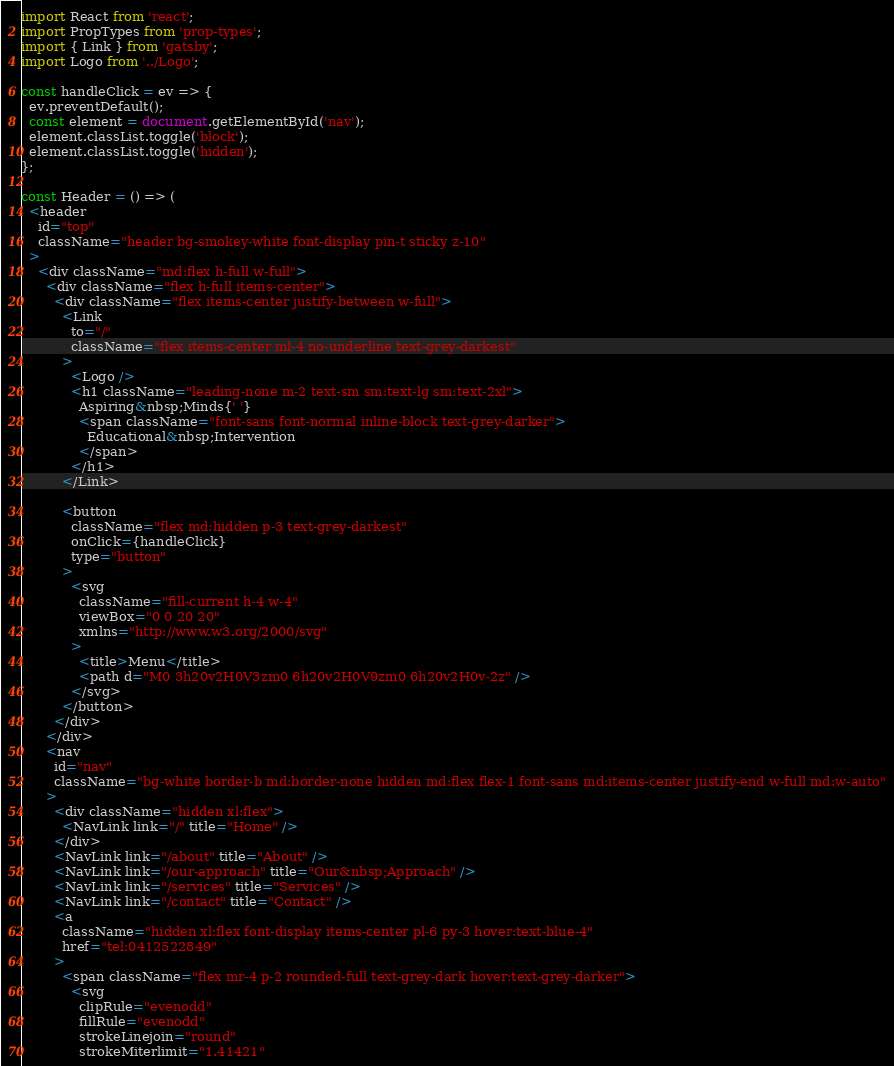Convert code to text. <code><loc_0><loc_0><loc_500><loc_500><_JavaScript_>import React from 'react';
import PropTypes from 'prop-types';
import { Link } from 'gatsby';
import Logo from '../Logo';

const handleClick = ev => {
  ev.preventDefault();
  const element = document.getElementById('nav');
  element.classList.toggle('block');
  element.classList.toggle('hidden');
};

const Header = () => (
  <header
    id="top"
    className="header bg-smokey-white font-display pin-t sticky z-10"
  >
    <div className="md:flex h-full w-full">
      <div className="flex h-full items-center">
        <div className="flex items-center justify-between w-full">
          <Link
            to="/"
            className="flex items-center ml-4 no-underline text-grey-darkest"
          >
            <Logo />
            <h1 className="leading-none m-2 text-sm sm:text-lg sm:text-2xl">
              Aspiring&nbsp;Minds{' '}
              <span className="font-sans font-normal inline-block text-grey-darker">
                Educational&nbsp;Intervention
              </span>
            </h1>
          </Link>

          <button
            className="flex md:hidden p-3 text-grey-darkest"
            onClick={handleClick}
            type="button"
          >
            <svg
              className="fill-current h-4 w-4"
              viewBox="0 0 20 20"
              xmlns="http://www.w3.org/2000/svg"
            >
              <title>Menu</title>
              <path d="M0 3h20v2H0V3zm0 6h20v2H0V9zm0 6h20v2H0v-2z" />
            </svg>
          </button>
        </div>
      </div>
      <nav
        id="nav"
        className="bg-white border-b md:border-none hidden md:flex flex-1 font-sans md:items-center justify-end w-full md:w-auto"
      >
        <div className="hidden xl:flex">
          <NavLink link="/" title="Home" />
        </div>
        <NavLink link="/about" title="About" />
        <NavLink link="/our-approach" title="Our&nbsp;Approach" />
        <NavLink link="/services" title="Services" />
        <NavLink link="/contact" title="Contact" />
        <a
          className="hidden xl:flex font-display items-center pl-6 py-3 hover:text-blue-4"
          href="tel:0412522849"
        >
          <span className="flex mr-4 p-2 rounded-full text-grey-dark hover:text-grey-darker">
            <svg
              clipRule="evenodd"
              fillRule="evenodd"
              strokeLinejoin="round"
              strokeMiterlimit="1.41421"</code> 